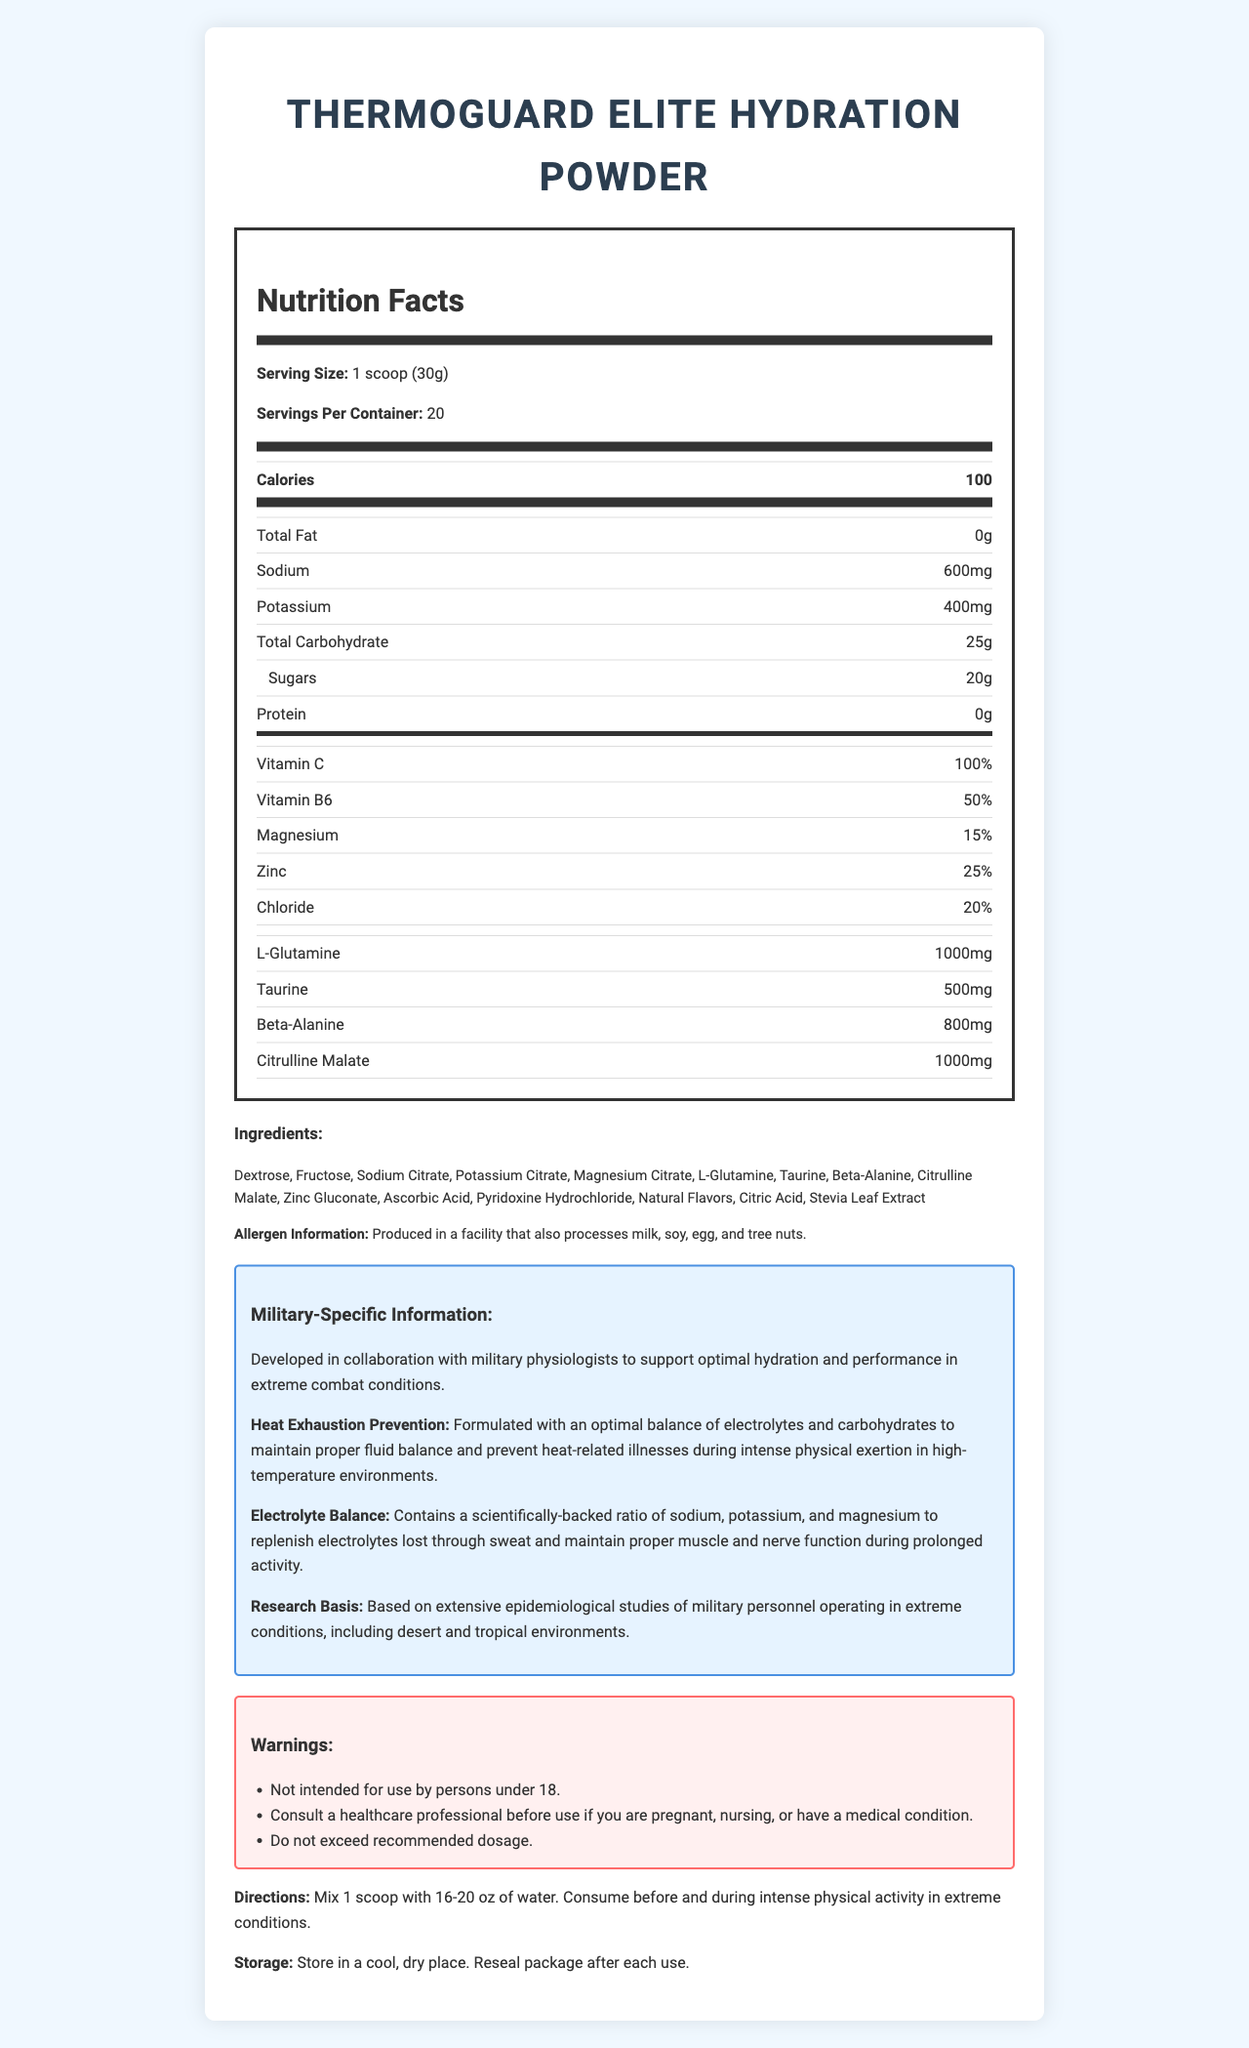what is the serving size for ThermoGuard Elite Hydration Powder? The serving size is listed at the top of the Nutrition Facts section of the document as "Serving Size: 1 scoop (30g)".
Answer: 1 scoop (30g) how many calories are in a serving of the hydration powder? The calorie content per serving is listed in the Nutrition Facts section under the heading "Calories".
Answer: 100 how much sodium is present in one serving? The amount of sodium per serving is listed in the Nutrition Facts section as "Sodium: 600mg".
Answer: 600mg which ingredient is used as a sweetener in this product? The ingredient list includes "Stevia Leaf Extract," which is known for its use as a natural sweetener.
Answer: Stevia Leaf Extract how should this product be stored? The storage instructions are provided at the end of the document under "Storage".
Answer: Store in a cool, dry place. Reseal package after each use. what is the main purpose of this hydration powder? A. Weight loss B. Muscle gain C. Hydration and electrolyte balance D. Joint health The main purpose, as stated in multiple sections of the document, is to maintain hydration and electrolyte balance, particularly in extreme conditions.
Answer: C which of the following is an ingredient not listed in ThermoGuard Elite Hydration Powder? A. Sodium Citrate B. Ascorbic Acid C. Calcium Carbonate D. Citric Acid Calcium Carbonate is not listed among the ingredients of this product.
Answer: C does this product contain any protein? The Nutrition Facts section shows "Protein: 0g," indicating that there is no protein in this product.
Answer: No should individuals under 18 years old use this product? One of the warnings clearly states, "Not intended for use by persons under 18."
Answer: No summarize the main purpose and components of ThermoGuard Elite Hydration Powder. The document gives a detailed overview of the product's purpose, nutritional content, ingredients, and specific usage warnings, emphasizing its role in hydration and electrolyte maintenance during extreme physical exertion.
Answer: ThermoGuard Elite Hydration Powder is designed to prevent heat-related illnesses and maintain electrolyte balance during intense physical activities, especially in extreme conditions. It contains a balanced blend of electrolytes like sodium, potassium, and magnesium, along with carbohydrates and specific amino acids. The product is backed by research conducted on military personnel in harsh environments. It is intended for use by mixing with water and is not recommended for individuals under 18. what is the exact ratio of sodium to potassium in this supplement? The document does not explicitly provide a ratio; it only lists their individual amounts per serving (600mg of sodium and 400mg of potassium).
Answer: Not enough information why might someone consult a healthcare professional before using this product? One of the warnings advises consultation with a healthcare professional if the user is pregnant, nursing, or has a medical condition.
Answer: They should consult if they are pregnant, nursing, or have a medical condition. 